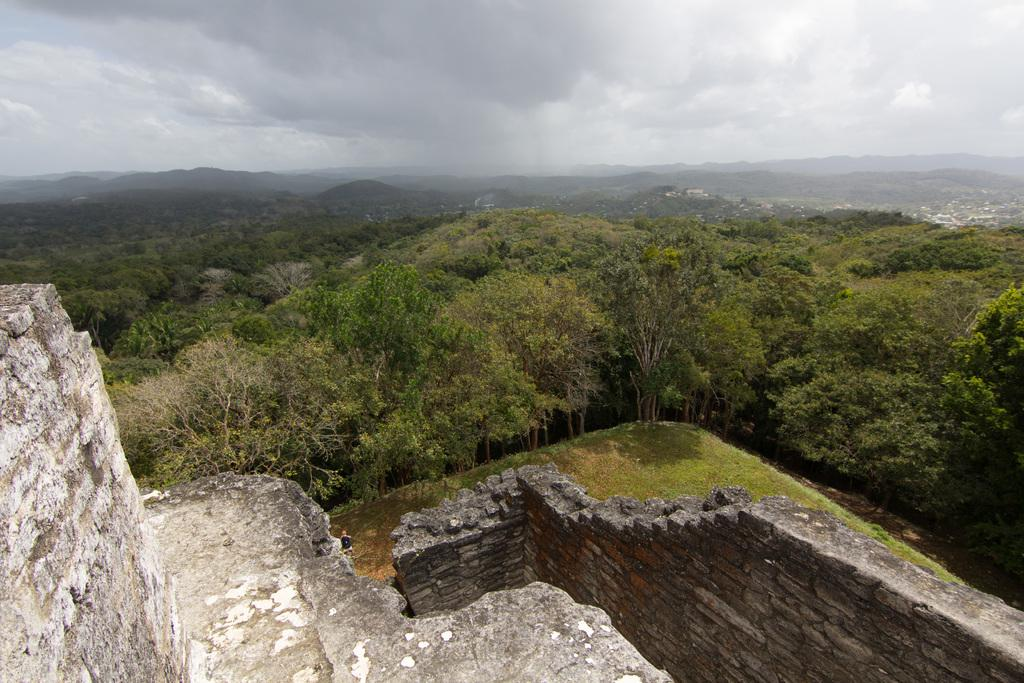What type of vegetation can be seen in the image? There are trees in the image. How are the trees distributed in the image? The trees are spread throughout the image. What can be seen in the background of the image? There are hills in the background of the image. What is located in the front of the image? There is a stone construction in the front of the image. What is visible in the sky in the image? The sky is visible in the image, and clouds are present. What type of cream is being produced by the trees in the image? There is no cream being produced by the trees in the image; they are simply trees. 